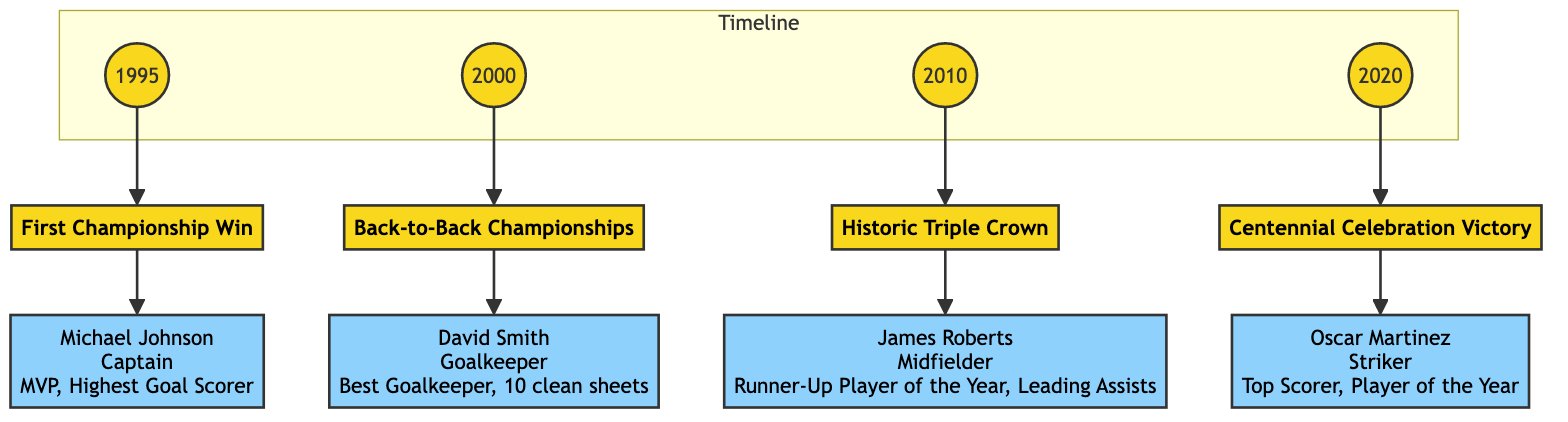What is the title of the diagram? The title is clearly stated at the top of the diagram, which is typically provided in a header section. In this case, it is "Milestones of Major Wins and Championships with Influential Players."
Answer: Milestones of Major Wins and Championships with Influential Players How many milestones are included in the diagram? By counting the distinct milestone blocks depicted in the diagram, there are four milestones: First Championship Win, Back-to-Back Championships, Historic Triple Crown, and Centennial Celebration Victory.
Answer: 4 What year did the team achieve their first championship win? The corresponding node in the diagram displays the year associated with the first milestone, which is 1995. This information is directly linked to the milestone block.
Answer: 1995 Who was the influential player during the Historic Triple Crown win? The influential player's name can be found directly connected to the Historic Triple Crown milestone block. His name, James Roberts, is indicated, showing his role as a significant contributor.
Answer: James Roberts What award did David Smith receive? The details connected to the Back-to-Back Championships milestone mention that David Smith won the "Best Goalkeeper Award," which specifies one of his achievements.
Answer: Best Goalkeeper Award Which milestone directly follows the year 2000 in the timeline? By examining the connections in the diagram, the Back-to-Back Championships block is directly linked to the year 2000, indicating it as the next milestone following that year.
Answer: Back-to-Back Championships What is one of Oscar Martinez's achievements mentioned in the diagram? The diagram lists Oscar Martinez’s notable achievements under the Centennial Celebration Victory block, and one of them is "Top Scorer of the Season," providing a specific detail of his accomplishments.
Answer: Top Scorer of the Season What role did Michael Johnson play in the team during the first championship win? The diagram specifies that Michael Johnson served as Captain during the first championship win, clearly stating his role alongside his achievements.
Answer: Captain How many clean sheets did David Smith record? The relevant milestone details provide that David Smith achieved a record of 10 clean sheets during the back-to-back championships, directly answering the question about his performance.
Answer: 10 